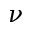<formula> <loc_0><loc_0><loc_500><loc_500>\nu</formula> 